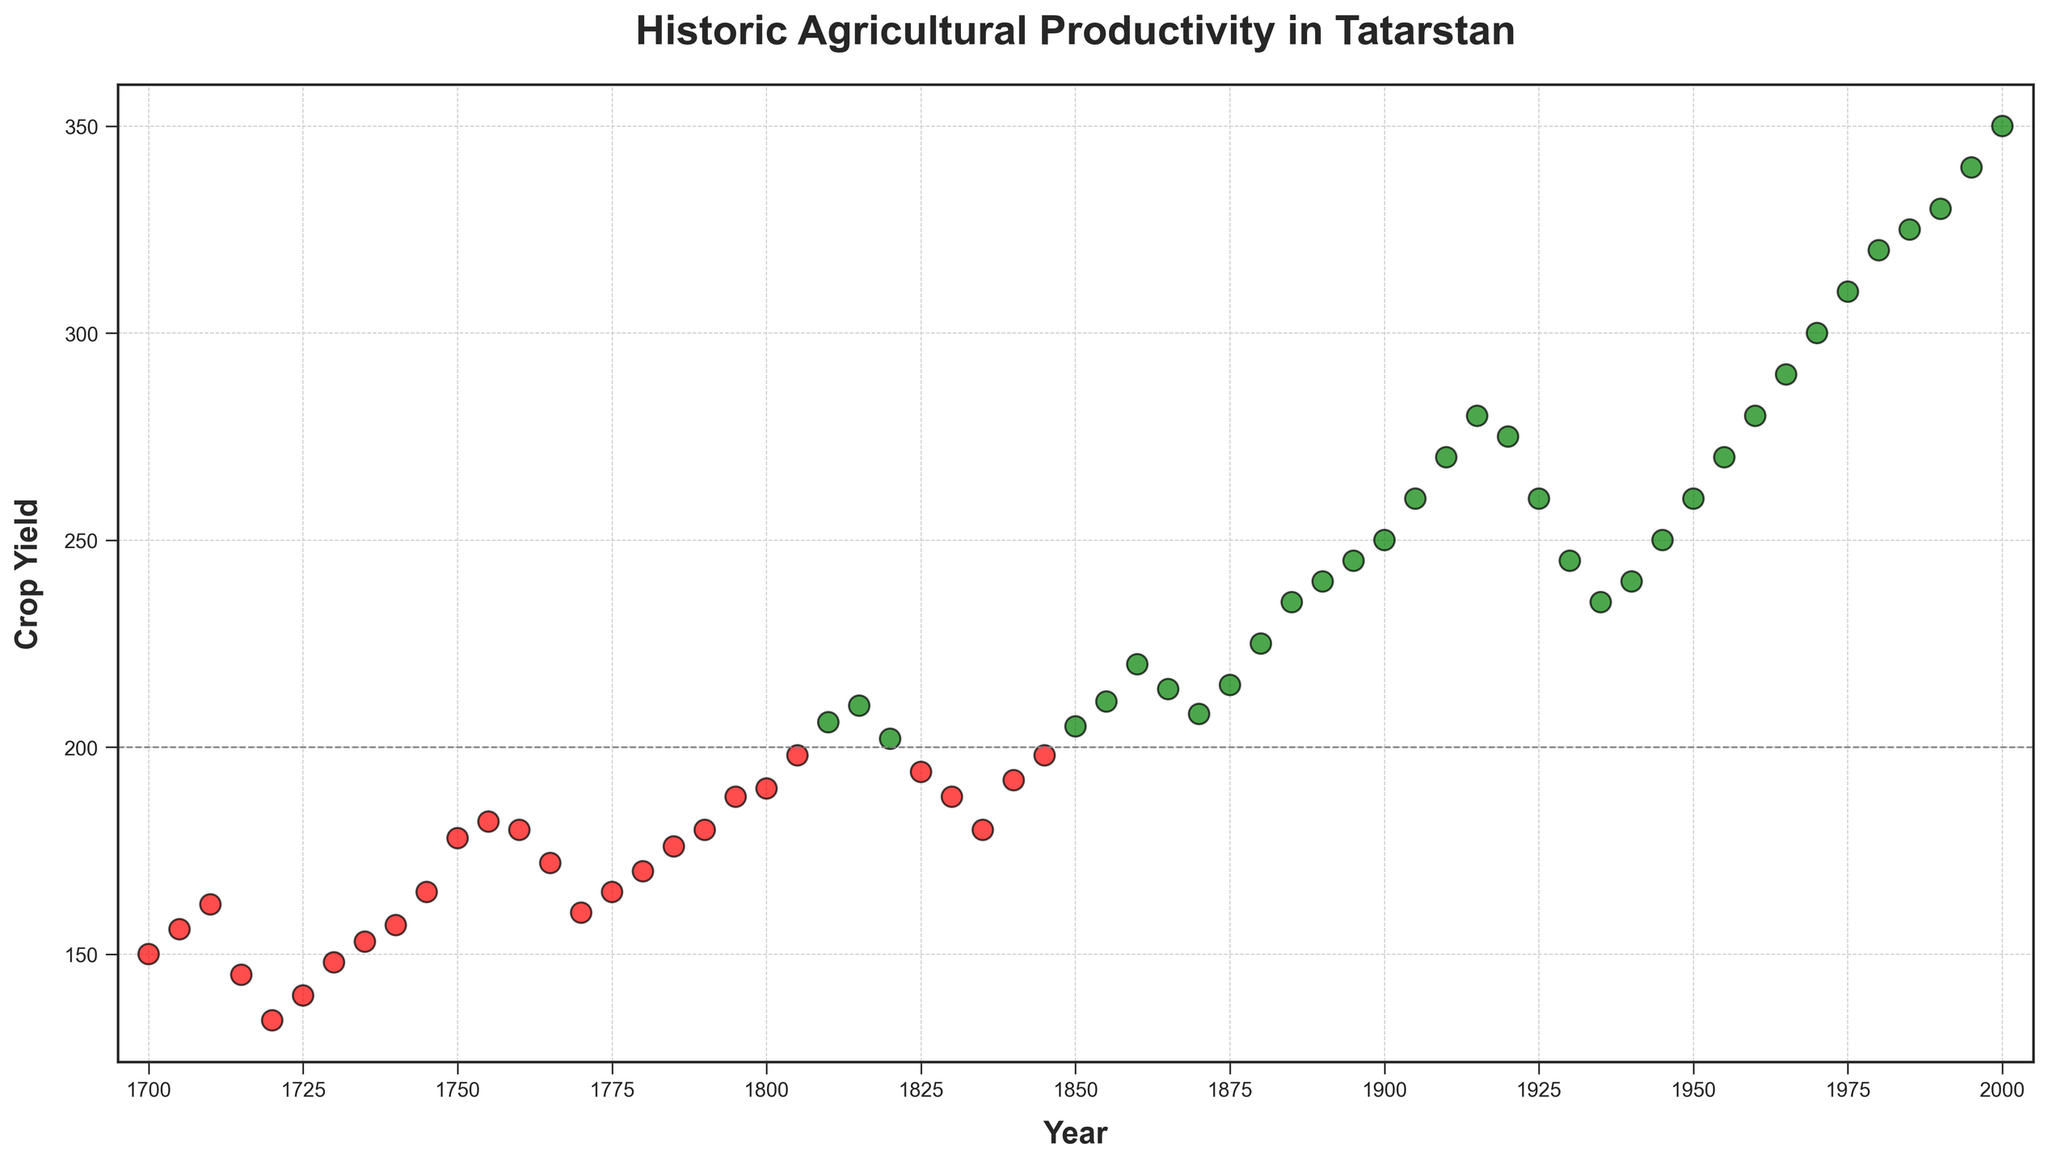What period showed the longest overall increase in crop yield? Look for the longest stretch between two years where the yield consistently increased. From 1900 to 1995, the crop yield steadily increases from 250 to 340.
Answer: 1900-1995 How many times does the crop yield exceed 200? Count the points in the scatter plot that are above the gray horizontal line at the crop yield value of 200. The years are: 1805–1995.
Answer: 34 During which 10-year span did crop yield decrease the most? Compare differences between crop yields of ten consecutive years. Between 1920 and 1930, the yield decreased from 275 to 245, a drop of 30 units.
Answer: 1920-1930 What years did the crop yield fall below 140, and what were the corresponding yields? Identify the red points below the y-value of 140 and check their respective years. The yield fell below 140 in the years 1720 (134) and 1725 (140).
Answer: 1720 (134), 1725 (140) Which year demonstrates the highest crop yield, and what is its value? Identify the highest point on the y-axis. The maximum yield is in 2000 with a value of 350.
Answer: 2000, 350 What is the difference in crop yield between 1750 and 1925? Subtract the crop yield value in 1750 (178) from that in 1925 (260).
Answer: 82 When did crop yield first surpass 200, and what was its value? Look for the first year where the crop yield crosses the gray horizontal line at 200. It first surpasses 200 in 1810 with a value of 206.
Answer: 1810, 206 How does the crop yield of 1850 compare to that of 1950? Compare the y-values of both years. The yield in 1850 was 205 and in 1950 it was 260, so 1950 had a higher yield.
Answer: 1950 had a higher yield by 55 What was the approximate average crop yield between 1700 and 1750? Average the crop yields for the years between 1700 (150) and 1750 (178). The average is calculated as (150+156+162+145+134+140+148+153+157+165+178)/11 ≈ 152.
Answer: 152 